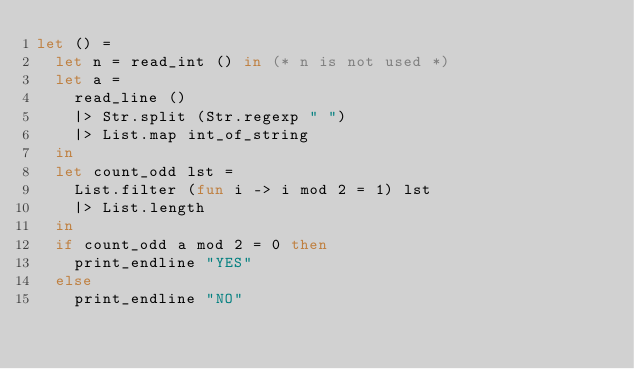<code> <loc_0><loc_0><loc_500><loc_500><_OCaml_>let () =
	let n = read_int () in (* n is not used *)
	let a =
		read_line ()
		|> Str.split (Str.regexp " ")
		|> List.map int_of_string
	in
	let count_odd lst =
		List.filter (fun i -> i mod 2 = 1) lst
		|> List.length
	in
	if count_odd a mod 2 = 0 then
		print_endline "YES"
	else
		print_endline "NO"
</code> 